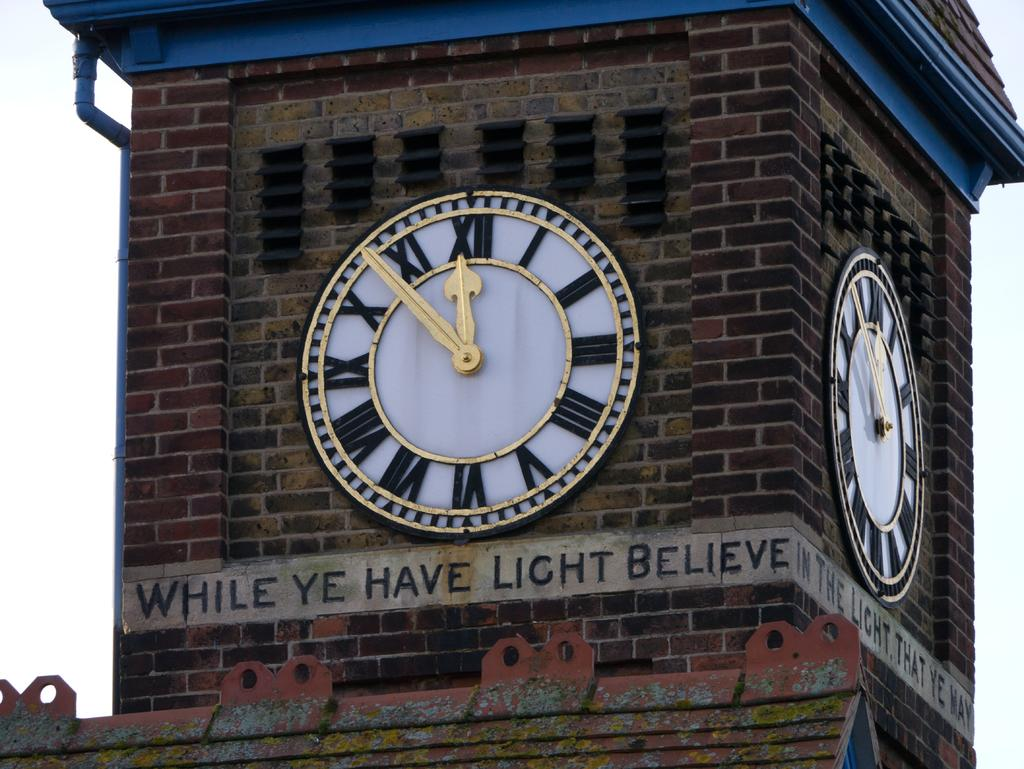Provide a one-sentence caption for the provided image. Sign below a clock that says While ye have light believe. 